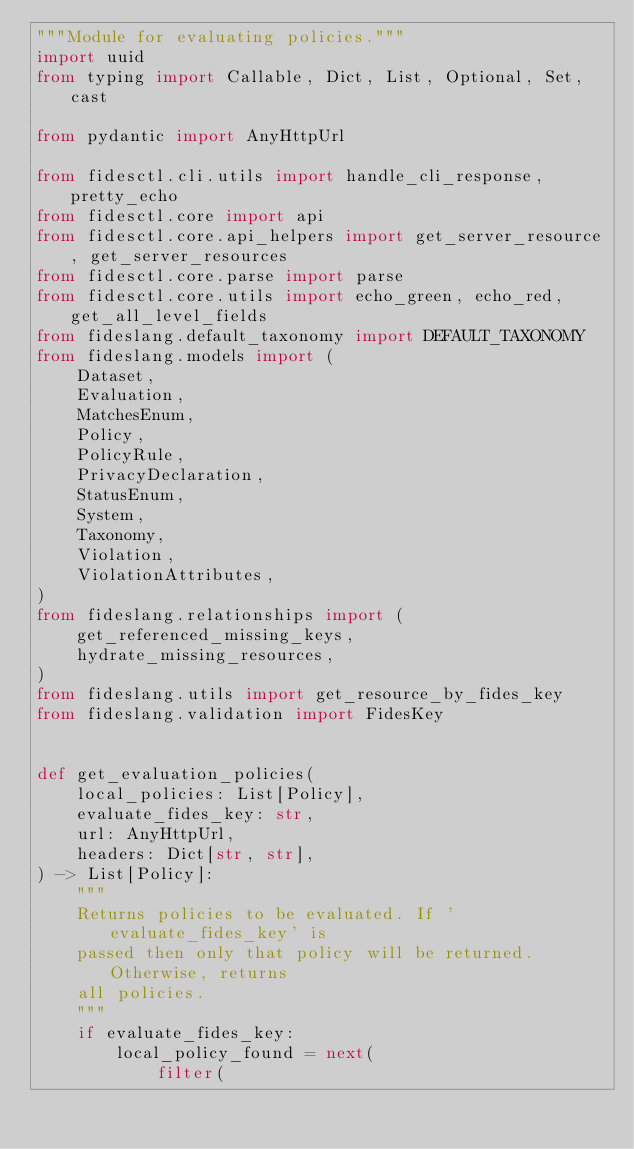Convert code to text. <code><loc_0><loc_0><loc_500><loc_500><_Python_>"""Module for evaluating policies."""
import uuid
from typing import Callable, Dict, List, Optional, Set, cast

from pydantic import AnyHttpUrl

from fidesctl.cli.utils import handle_cli_response, pretty_echo
from fidesctl.core import api
from fidesctl.core.api_helpers import get_server_resource, get_server_resources
from fidesctl.core.parse import parse
from fidesctl.core.utils import echo_green, echo_red, get_all_level_fields
from fideslang.default_taxonomy import DEFAULT_TAXONOMY
from fideslang.models import (
    Dataset,
    Evaluation,
    MatchesEnum,
    Policy,
    PolicyRule,
    PrivacyDeclaration,
    StatusEnum,
    System,
    Taxonomy,
    Violation,
    ViolationAttributes,
)
from fideslang.relationships import (
    get_referenced_missing_keys,
    hydrate_missing_resources,
)
from fideslang.utils import get_resource_by_fides_key
from fideslang.validation import FidesKey


def get_evaluation_policies(
    local_policies: List[Policy],
    evaluate_fides_key: str,
    url: AnyHttpUrl,
    headers: Dict[str, str],
) -> List[Policy]:
    """
    Returns policies to be evaluated. If 'evaluate_fides_key' is
    passed then only that policy will be returned. Otherwise, returns
    all policies.
    """
    if evaluate_fides_key:
        local_policy_found = next(
            filter(</code> 